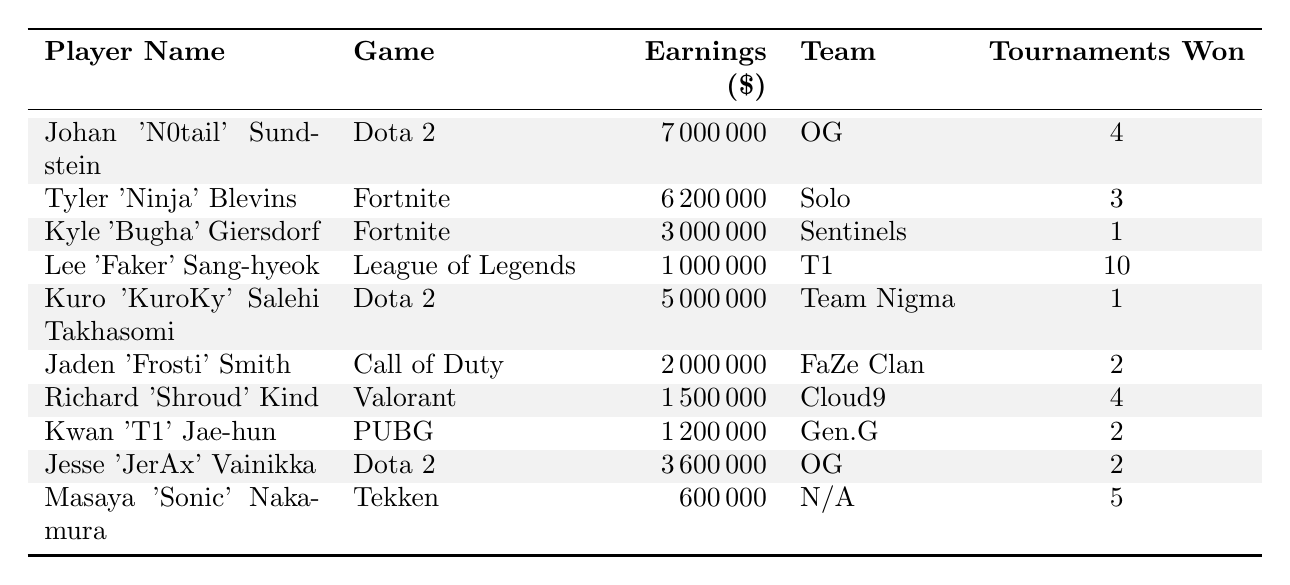What is the highest earning among the players? You can find the earnings listed in the table. The player with the highest earnings is Johan 'N0tail' Sundstein with 7,000,000 dollars.
Answer: 7,000,000 Which game has the player with the most tournaments won? By examining the "Tournaments Won" column, Lee 'Faker' Sang-hyeok has the most with 10 tournaments won in League of Legends.
Answer: League of Legends What is the total earnings of players from Dota 2? The earnings for Dota 2 players are 7,000,000 (N0tail) + 5,000,000 (KuroKy) + 3,600,000 (JerAx) = 15,600,000.
Answer: 15,600,000 Is Tyler 'Ninja' Blevins’ team listed in the table? The table shows that Tyler 'Ninja' Blevins plays as a solo player, which is indeed listed.
Answer: Yes How much more did Johan 'N0tail' Sundstein earn than Kyle 'Bugha' Giersdorf? To find the difference, subtract Bugha's earnings (3,000,000) from N0tail's earnings (7,000,000), resulting in 7,000,000 - 3,000,000 = 4,000,000.
Answer: 4,000,000 What percentage of total earnings does the top player represent if total earnings sum up to 30,000,000? You calculate the percentage by (7,000,000 / 30,000,000) * 100, which equals approximately 23.33%.
Answer: 23.33% Which player has the least earnings and how much is that? The table shows that Masaya 'Sonic' Nakamura has the least earnings at 600,000 dollars.
Answer: 600,000 How many total tournaments did Dota 2 players win together? Adding the tournaments won by Dota 2 players: 4 (N0tail) + 1 (KuroKy) + 2 (JerAx) = 7 tournaments.
Answer: 7 Has any player won more than 10 tournaments? The table shows Lee 'Faker' Sang-hyeok has won 10 tournaments, which is equal but not more than 10.
Answer: No Which game has the second highest total earnings among the players listed? Calculating the total earnings for Fortnite: 6,200,000 (Ninja) + 3,000,000 (Bugha) = 9,200,000, which is the second highest after Dota 2's 15,600,000.
Answer: Fortnite 